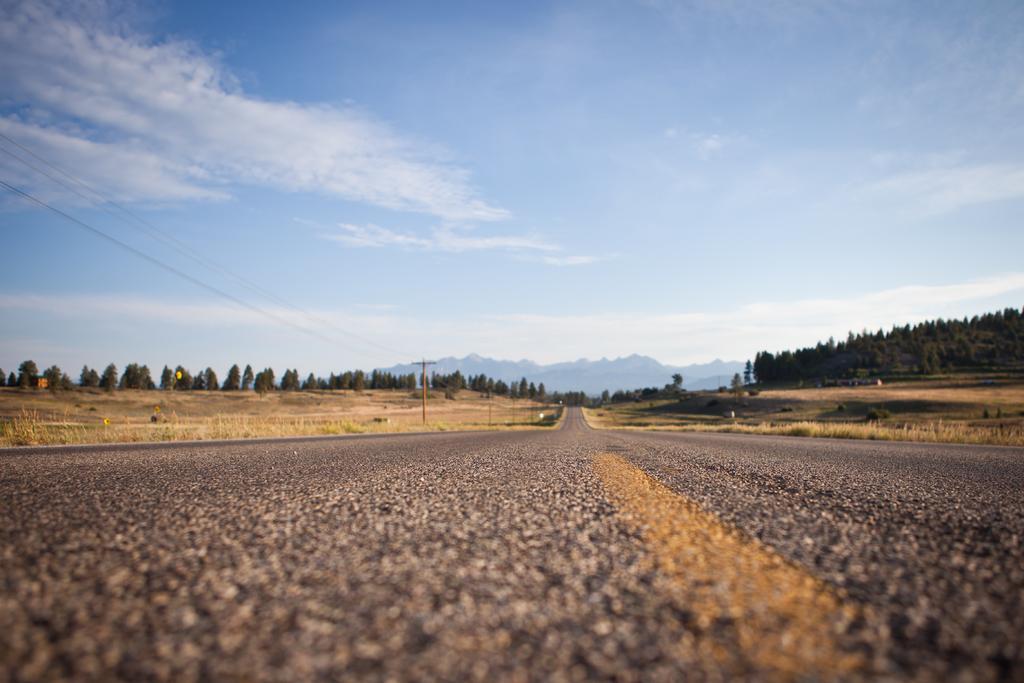In one or two sentences, can you explain what this image depicts? In this picture I can observe a road in the middle of the picture. In the background I can observe trees, hills and some clouds in the sky. 